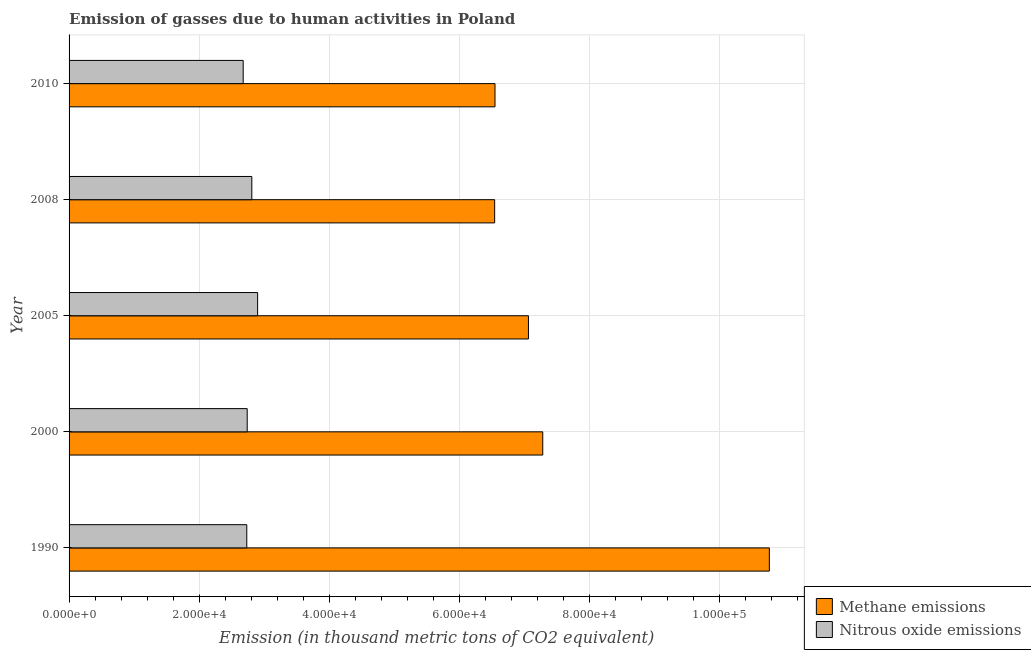How many bars are there on the 5th tick from the bottom?
Provide a succinct answer. 2. What is the label of the 2nd group of bars from the top?
Provide a short and direct response. 2008. What is the amount of nitrous oxide emissions in 2010?
Your answer should be compact. 2.68e+04. Across all years, what is the maximum amount of methane emissions?
Provide a short and direct response. 1.08e+05. Across all years, what is the minimum amount of methane emissions?
Keep it short and to the point. 6.54e+04. In which year was the amount of nitrous oxide emissions maximum?
Your response must be concise. 2005. In which year was the amount of methane emissions minimum?
Provide a succinct answer. 2008. What is the total amount of nitrous oxide emissions in the graph?
Give a very brief answer. 1.38e+05. What is the difference between the amount of methane emissions in 1990 and that in 2010?
Offer a very short reply. 4.22e+04. What is the difference between the amount of methane emissions in 2008 and the amount of nitrous oxide emissions in 2010?
Give a very brief answer. 3.86e+04. What is the average amount of methane emissions per year?
Offer a terse response. 7.64e+04. In the year 2010, what is the difference between the amount of nitrous oxide emissions and amount of methane emissions?
Provide a short and direct response. -3.87e+04. In how many years, is the amount of methane emissions greater than 64000 thousand metric tons?
Your response must be concise. 5. What is the ratio of the amount of methane emissions in 1990 to that in 2005?
Your answer should be very brief. 1.52. Is the amount of nitrous oxide emissions in 2000 less than that in 2010?
Your response must be concise. No. Is the difference between the amount of nitrous oxide emissions in 2000 and 2010 greater than the difference between the amount of methane emissions in 2000 and 2010?
Offer a very short reply. No. What is the difference between the highest and the second highest amount of methane emissions?
Keep it short and to the point. 3.48e+04. What is the difference between the highest and the lowest amount of nitrous oxide emissions?
Offer a very short reply. 2218. Is the sum of the amount of nitrous oxide emissions in 2000 and 2010 greater than the maximum amount of methane emissions across all years?
Give a very brief answer. No. What does the 2nd bar from the top in 2005 represents?
Give a very brief answer. Methane emissions. What does the 1st bar from the bottom in 2000 represents?
Ensure brevity in your answer.  Methane emissions. How many bars are there?
Give a very brief answer. 10. Are all the bars in the graph horizontal?
Provide a succinct answer. Yes. What is the difference between two consecutive major ticks on the X-axis?
Make the answer very short. 2.00e+04. Are the values on the major ticks of X-axis written in scientific E-notation?
Offer a terse response. Yes. Does the graph contain any zero values?
Provide a short and direct response. No. Where does the legend appear in the graph?
Offer a very short reply. Bottom right. How are the legend labels stacked?
Offer a very short reply. Vertical. What is the title of the graph?
Make the answer very short. Emission of gasses due to human activities in Poland. What is the label or title of the X-axis?
Offer a terse response. Emission (in thousand metric tons of CO2 equivalent). What is the label or title of the Y-axis?
Ensure brevity in your answer.  Year. What is the Emission (in thousand metric tons of CO2 equivalent) in Methane emissions in 1990?
Your response must be concise. 1.08e+05. What is the Emission (in thousand metric tons of CO2 equivalent) in Nitrous oxide emissions in 1990?
Offer a very short reply. 2.73e+04. What is the Emission (in thousand metric tons of CO2 equivalent) in Methane emissions in 2000?
Your answer should be compact. 7.28e+04. What is the Emission (in thousand metric tons of CO2 equivalent) of Nitrous oxide emissions in 2000?
Ensure brevity in your answer.  2.74e+04. What is the Emission (in thousand metric tons of CO2 equivalent) of Methane emissions in 2005?
Provide a short and direct response. 7.06e+04. What is the Emission (in thousand metric tons of CO2 equivalent) of Nitrous oxide emissions in 2005?
Offer a very short reply. 2.90e+04. What is the Emission (in thousand metric tons of CO2 equivalent) in Methane emissions in 2008?
Offer a terse response. 6.54e+04. What is the Emission (in thousand metric tons of CO2 equivalent) of Nitrous oxide emissions in 2008?
Ensure brevity in your answer.  2.81e+04. What is the Emission (in thousand metric tons of CO2 equivalent) of Methane emissions in 2010?
Your answer should be compact. 6.55e+04. What is the Emission (in thousand metric tons of CO2 equivalent) of Nitrous oxide emissions in 2010?
Your answer should be compact. 2.68e+04. Across all years, what is the maximum Emission (in thousand metric tons of CO2 equivalent) in Methane emissions?
Offer a very short reply. 1.08e+05. Across all years, what is the maximum Emission (in thousand metric tons of CO2 equivalent) in Nitrous oxide emissions?
Provide a short and direct response. 2.90e+04. Across all years, what is the minimum Emission (in thousand metric tons of CO2 equivalent) in Methane emissions?
Your response must be concise. 6.54e+04. Across all years, what is the minimum Emission (in thousand metric tons of CO2 equivalent) in Nitrous oxide emissions?
Provide a succinct answer. 2.68e+04. What is the total Emission (in thousand metric tons of CO2 equivalent) in Methane emissions in the graph?
Your response must be concise. 3.82e+05. What is the total Emission (in thousand metric tons of CO2 equivalent) of Nitrous oxide emissions in the graph?
Offer a terse response. 1.38e+05. What is the difference between the Emission (in thousand metric tons of CO2 equivalent) in Methane emissions in 1990 and that in 2000?
Your answer should be compact. 3.48e+04. What is the difference between the Emission (in thousand metric tons of CO2 equivalent) of Nitrous oxide emissions in 1990 and that in 2000?
Your answer should be very brief. -66.8. What is the difference between the Emission (in thousand metric tons of CO2 equivalent) of Methane emissions in 1990 and that in 2005?
Your answer should be very brief. 3.70e+04. What is the difference between the Emission (in thousand metric tons of CO2 equivalent) of Nitrous oxide emissions in 1990 and that in 2005?
Your response must be concise. -1667.4. What is the difference between the Emission (in thousand metric tons of CO2 equivalent) of Methane emissions in 1990 and that in 2008?
Your answer should be very brief. 4.22e+04. What is the difference between the Emission (in thousand metric tons of CO2 equivalent) of Nitrous oxide emissions in 1990 and that in 2008?
Offer a very short reply. -773.9. What is the difference between the Emission (in thousand metric tons of CO2 equivalent) of Methane emissions in 1990 and that in 2010?
Provide a short and direct response. 4.22e+04. What is the difference between the Emission (in thousand metric tons of CO2 equivalent) in Nitrous oxide emissions in 1990 and that in 2010?
Provide a succinct answer. 550.6. What is the difference between the Emission (in thousand metric tons of CO2 equivalent) in Methane emissions in 2000 and that in 2005?
Your answer should be compact. 2197.9. What is the difference between the Emission (in thousand metric tons of CO2 equivalent) of Nitrous oxide emissions in 2000 and that in 2005?
Give a very brief answer. -1600.6. What is the difference between the Emission (in thousand metric tons of CO2 equivalent) of Methane emissions in 2000 and that in 2008?
Provide a succinct answer. 7391.3. What is the difference between the Emission (in thousand metric tons of CO2 equivalent) in Nitrous oxide emissions in 2000 and that in 2008?
Ensure brevity in your answer.  -707.1. What is the difference between the Emission (in thousand metric tons of CO2 equivalent) of Methane emissions in 2000 and that in 2010?
Make the answer very short. 7338.4. What is the difference between the Emission (in thousand metric tons of CO2 equivalent) of Nitrous oxide emissions in 2000 and that in 2010?
Provide a short and direct response. 617.4. What is the difference between the Emission (in thousand metric tons of CO2 equivalent) of Methane emissions in 2005 and that in 2008?
Provide a succinct answer. 5193.4. What is the difference between the Emission (in thousand metric tons of CO2 equivalent) in Nitrous oxide emissions in 2005 and that in 2008?
Ensure brevity in your answer.  893.5. What is the difference between the Emission (in thousand metric tons of CO2 equivalent) in Methane emissions in 2005 and that in 2010?
Offer a very short reply. 5140.5. What is the difference between the Emission (in thousand metric tons of CO2 equivalent) of Nitrous oxide emissions in 2005 and that in 2010?
Make the answer very short. 2218. What is the difference between the Emission (in thousand metric tons of CO2 equivalent) in Methane emissions in 2008 and that in 2010?
Keep it short and to the point. -52.9. What is the difference between the Emission (in thousand metric tons of CO2 equivalent) in Nitrous oxide emissions in 2008 and that in 2010?
Offer a very short reply. 1324.5. What is the difference between the Emission (in thousand metric tons of CO2 equivalent) of Methane emissions in 1990 and the Emission (in thousand metric tons of CO2 equivalent) of Nitrous oxide emissions in 2000?
Your response must be concise. 8.02e+04. What is the difference between the Emission (in thousand metric tons of CO2 equivalent) of Methane emissions in 1990 and the Emission (in thousand metric tons of CO2 equivalent) of Nitrous oxide emissions in 2005?
Give a very brief answer. 7.86e+04. What is the difference between the Emission (in thousand metric tons of CO2 equivalent) of Methane emissions in 1990 and the Emission (in thousand metric tons of CO2 equivalent) of Nitrous oxide emissions in 2008?
Ensure brevity in your answer.  7.95e+04. What is the difference between the Emission (in thousand metric tons of CO2 equivalent) of Methane emissions in 1990 and the Emission (in thousand metric tons of CO2 equivalent) of Nitrous oxide emissions in 2010?
Your answer should be compact. 8.09e+04. What is the difference between the Emission (in thousand metric tons of CO2 equivalent) in Methane emissions in 2000 and the Emission (in thousand metric tons of CO2 equivalent) in Nitrous oxide emissions in 2005?
Ensure brevity in your answer.  4.38e+04. What is the difference between the Emission (in thousand metric tons of CO2 equivalent) of Methane emissions in 2000 and the Emission (in thousand metric tons of CO2 equivalent) of Nitrous oxide emissions in 2008?
Offer a very short reply. 4.47e+04. What is the difference between the Emission (in thousand metric tons of CO2 equivalent) in Methane emissions in 2000 and the Emission (in thousand metric tons of CO2 equivalent) in Nitrous oxide emissions in 2010?
Your answer should be compact. 4.60e+04. What is the difference between the Emission (in thousand metric tons of CO2 equivalent) in Methane emissions in 2005 and the Emission (in thousand metric tons of CO2 equivalent) in Nitrous oxide emissions in 2008?
Offer a very short reply. 4.25e+04. What is the difference between the Emission (in thousand metric tons of CO2 equivalent) of Methane emissions in 2005 and the Emission (in thousand metric tons of CO2 equivalent) of Nitrous oxide emissions in 2010?
Your answer should be compact. 4.38e+04. What is the difference between the Emission (in thousand metric tons of CO2 equivalent) of Methane emissions in 2008 and the Emission (in thousand metric tons of CO2 equivalent) of Nitrous oxide emissions in 2010?
Give a very brief answer. 3.86e+04. What is the average Emission (in thousand metric tons of CO2 equivalent) of Methane emissions per year?
Keep it short and to the point. 7.64e+04. What is the average Emission (in thousand metric tons of CO2 equivalent) of Nitrous oxide emissions per year?
Your answer should be compact. 2.77e+04. In the year 1990, what is the difference between the Emission (in thousand metric tons of CO2 equivalent) of Methane emissions and Emission (in thousand metric tons of CO2 equivalent) of Nitrous oxide emissions?
Make the answer very short. 8.03e+04. In the year 2000, what is the difference between the Emission (in thousand metric tons of CO2 equivalent) in Methane emissions and Emission (in thousand metric tons of CO2 equivalent) in Nitrous oxide emissions?
Provide a short and direct response. 4.54e+04. In the year 2005, what is the difference between the Emission (in thousand metric tons of CO2 equivalent) in Methane emissions and Emission (in thousand metric tons of CO2 equivalent) in Nitrous oxide emissions?
Your answer should be compact. 4.16e+04. In the year 2008, what is the difference between the Emission (in thousand metric tons of CO2 equivalent) in Methane emissions and Emission (in thousand metric tons of CO2 equivalent) in Nitrous oxide emissions?
Give a very brief answer. 3.73e+04. In the year 2010, what is the difference between the Emission (in thousand metric tons of CO2 equivalent) of Methane emissions and Emission (in thousand metric tons of CO2 equivalent) of Nitrous oxide emissions?
Offer a very short reply. 3.87e+04. What is the ratio of the Emission (in thousand metric tons of CO2 equivalent) in Methane emissions in 1990 to that in 2000?
Provide a short and direct response. 1.48. What is the ratio of the Emission (in thousand metric tons of CO2 equivalent) of Nitrous oxide emissions in 1990 to that in 2000?
Your answer should be very brief. 1. What is the ratio of the Emission (in thousand metric tons of CO2 equivalent) in Methane emissions in 1990 to that in 2005?
Ensure brevity in your answer.  1.52. What is the ratio of the Emission (in thousand metric tons of CO2 equivalent) in Nitrous oxide emissions in 1990 to that in 2005?
Provide a succinct answer. 0.94. What is the ratio of the Emission (in thousand metric tons of CO2 equivalent) in Methane emissions in 1990 to that in 2008?
Provide a short and direct response. 1.65. What is the ratio of the Emission (in thousand metric tons of CO2 equivalent) of Nitrous oxide emissions in 1990 to that in 2008?
Your answer should be very brief. 0.97. What is the ratio of the Emission (in thousand metric tons of CO2 equivalent) of Methane emissions in 1990 to that in 2010?
Your answer should be very brief. 1.64. What is the ratio of the Emission (in thousand metric tons of CO2 equivalent) of Nitrous oxide emissions in 1990 to that in 2010?
Give a very brief answer. 1.02. What is the ratio of the Emission (in thousand metric tons of CO2 equivalent) in Methane emissions in 2000 to that in 2005?
Offer a very short reply. 1.03. What is the ratio of the Emission (in thousand metric tons of CO2 equivalent) of Nitrous oxide emissions in 2000 to that in 2005?
Your response must be concise. 0.94. What is the ratio of the Emission (in thousand metric tons of CO2 equivalent) of Methane emissions in 2000 to that in 2008?
Offer a very short reply. 1.11. What is the ratio of the Emission (in thousand metric tons of CO2 equivalent) of Nitrous oxide emissions in 2000 to that in 2008?
Keep it short and to the point. 0.97. What is the ratio of the Emission (in thousand metric tons of CO2 equivalent) in Methane emissions in 2000 to that in 2010?
Keep it short and to the point. 1.11. What is the ratio of the Emission (in thousand metric tons of CO2 equivalent) of Nitrous oxide emissions in 2000 to that in 2010?
Offer a very short reply. 1.02. What is the ratio of the Emission (in thousand metric tons of CO2 equivalent) of Methane emissions in 2005 to that in 2008?
Your answer should be compact. 1.08. What is the ratio of the Emission (in thousand metric tons of CO2 equivalent) in Nitrous oxide emissions in 2005 to that in 2008?
Offer a very short reply. 1.03. What is the ratio of the Emission (in thousand metric tons of CO2 equivalent) in Methane emissions in 2005 to that in 2010?
Your response must be concise. 1.08. What is the ratio of the Emission (in thousand metric tons of CO2 equivalent) in Nitrous oxide emissions in 2005 to that in 2010?
Provide a short and direct response. 1.08. What is the ratio of the Emission (in thousand metric tons of CO2 equivalent) in Nitrous oxide emissions in 2008 to that in 2010?
Your answer should be compact. 1.05. What is the difference between the highest and the second highest Emission (in thousand metric tons of CO2 equivalent) of Methane emissions?
Your response must be concise. 3.48e+04. What is the difference between the highest and the second highest Emission (in thousand metric tons of CO2 equivalent) in Nitrous oxide emissions?
Keep it short and to the point. 893.5. What is the difference between the highest and the lowest Emission (in thousand metric tons of CO2 equivalent) in Methane emissions?
Give a very brief answer. 4.22e+04. What is the difference between the highest and the lowest Emission (in thousand metric tons of CO2 equivalent) in Nitrous oxide emissions?
Offer a very short reply. 2218. 